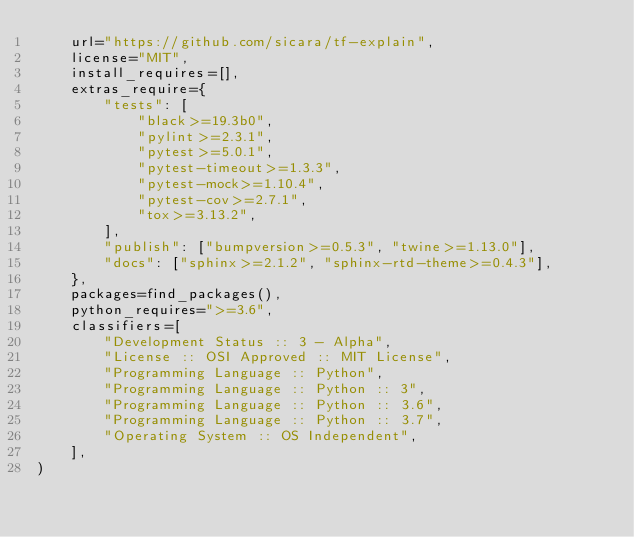Convert code to text. <code><loc_0><loc_0><loc_500><loc_500><_Python_>    url="https://github.com/sicara/tf-explain",
    license="MIT",
    install_requires=[],
    extras_require={
        "tests": [
            "black>=19.3b0",
            "pylint>=2.3.1",
            "pytest>=5.0.1",
            "pytest-timeout>=1.3.3",
            "pytest-mock>=1.10.4",
            "pytest-cov>=2.7.1",
            "tox>=3.13.2",
        ],
        "publish": ["bumpversion>=0.5.3", "twine>=1.13.0"],
        "docs": ["sphinx>=2.1.2", "sphinx-rtd-theme>=0.4.3"],
    },
    packages=find_packages(),
    python_requires=">=3.6",
    classifiers=[
        "Development Status :: 3 - Alpha",
        "License :: OSI Approved :: MIT License",
        "Programming Language :: Python",
        "Programming Language :: Python :: 3",
        "Programming Language :: Python :: 3.6",
        "Programming Language :: Python :: 3.7",
        "Operating System :: OS Independent",
    ],
)
</code> 